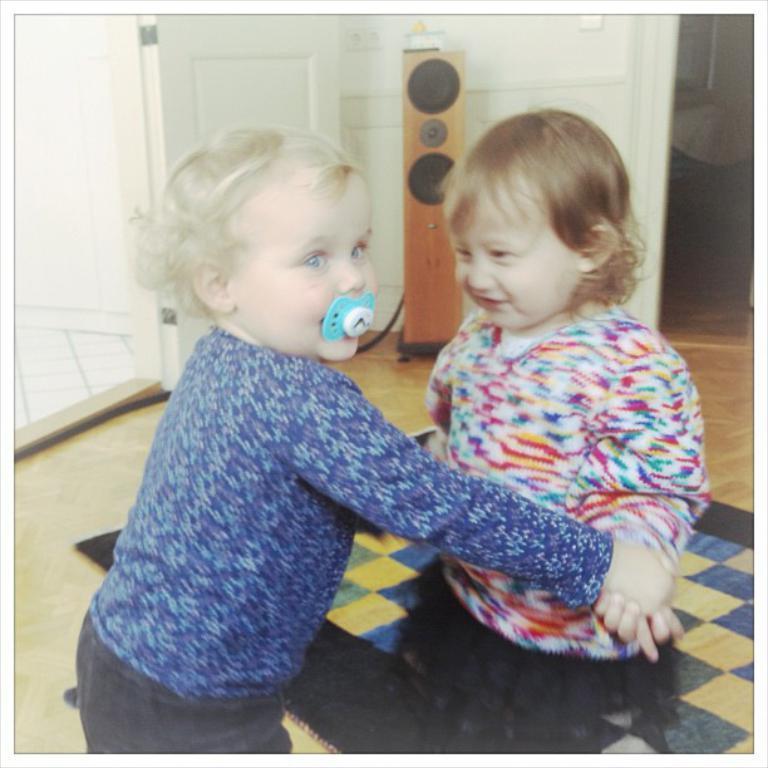Please provide a concise description of this image. In this picture there are two girls standing on the floor. Both of them are smiling. On the bottom right corner I can see the carpet. In the back I can see the speaker near to the door. At the top there are sockets. On the left I can see the bed near to the wall. 